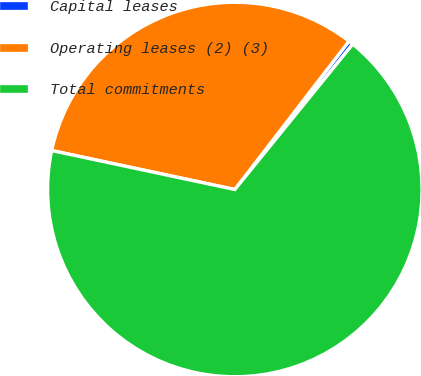Convert chart to OTSL. <chart><loc_0><loc_0><loc_500><loc_500><pie_chart><fcel>Capital leases<fcel>Operating leases (2) (3)<fcel>Total commitments<nl><fcel>0.41%<fcel>32.1%<fcel>67.49%<nl></chart> 